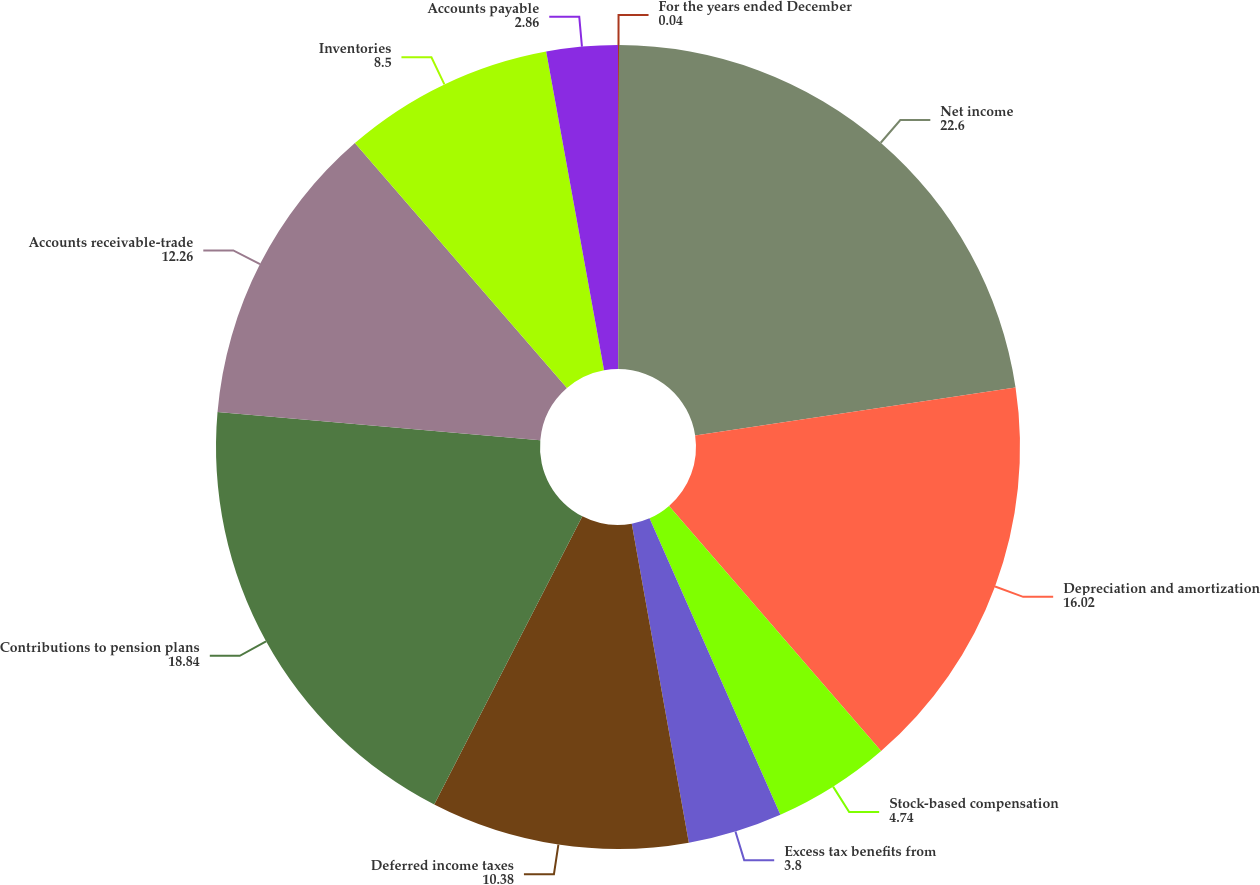Convert chart. <chart><loc_0><loc_0><loc_500><loc_500><pie_chart><fcel>For the years ended December<fcel>Net income<fcel>Depreciation and amortization<fcel>Stock-based compensation<fcel>Excess tax benefits from<fcel>Deferred income taxes<fcel>Contributions to pension plans<fcel>Accounts receivable-trade<fcel>Inventories<fcel>Accounts payable<nl><fcel>0.04%<fcel>22.6%<fcel>16.02%<fcel>4.74%<fcel>3.8%<fcel>10.38%<fcel>18.84%<fcel>12.26%<fcel>8.5%<fcel>2.86%<nl></chart> 